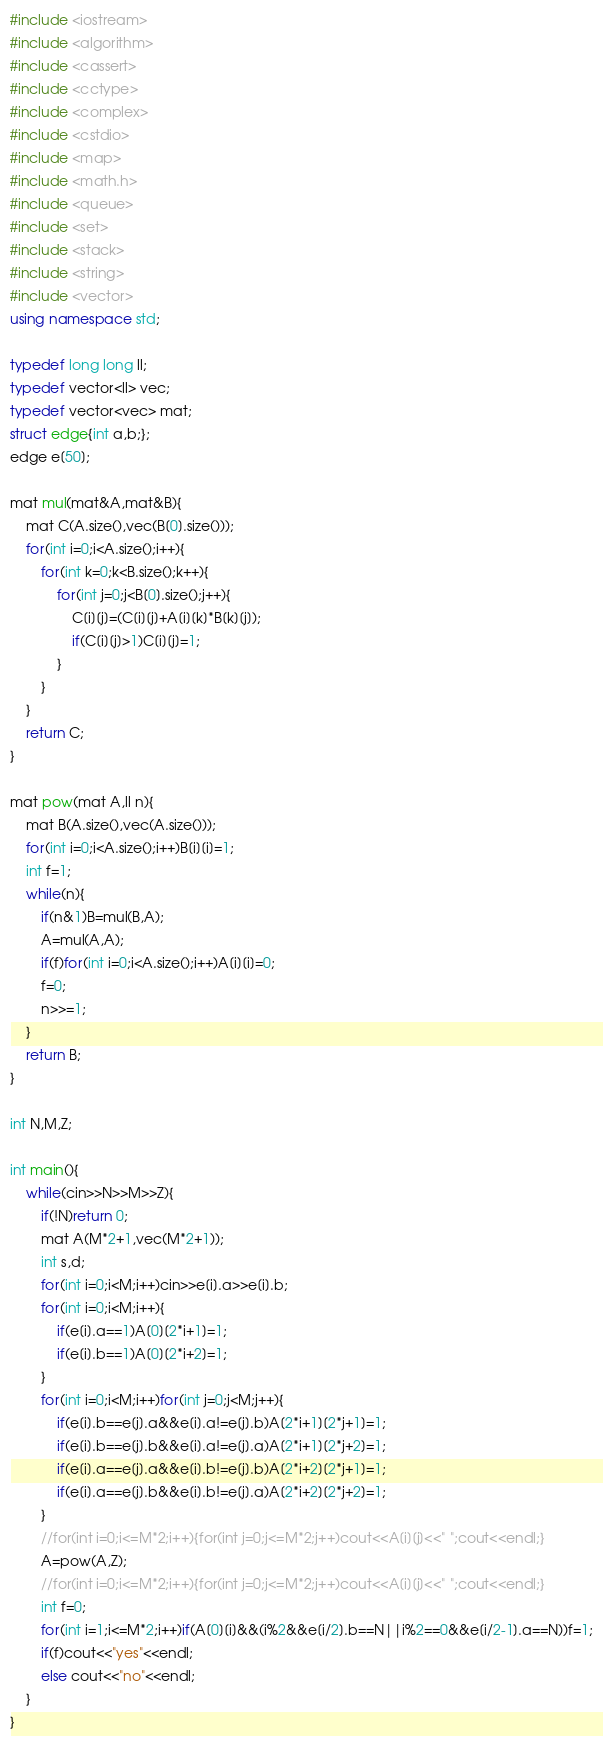<code> <loc_0><loc_0><loc_500><loc_500><_C++_>#include <iostream>
#include <algorithm>
#include <cassert>
#include <cctype>
#include <complex>
#include <cstdio>
#include <map>
#include <math.h>
#include <queue>
#include <set>
#include <stack>
#include <string>
#include <vector>
using namespace std;

typedef long long ll;
typedef vector<ll> vec;
typedef vector<vec> mat;
struct edge{int a,b;};
edge e[50];

mat mul(mat&A,mat&B){
	mat C(A.size(),vec(B[0].size()));
	for(int i=0;i<A.size();i++){
		for(int k=0;k<B.size();k++){
			for(int j=0;j<B[0].size();j++){
				C[i][j]=(C[i][j]+A[i][k]*B[k][j]);
				if(C[i][j]>1)C[i][j]=1;
			}
		}
	}
	return C;
}

mat pow(mat A,ll n){
	mat B(A.size(),vec(A.size()));
	for(int i=0;i<A.size();i++)B[i][i]=1;
	int f=1;
	while(n){
		if(n&1)B=mul(B,A);
		A=mul(A,A);
		if(f)for(int i=0;i<A.size();i++)A[i][i]=0;
		f=0;
		n>>=1;
	}
	return B;
}

int N,M,Z;

int main(){
	while(cin>>N>>M>>Z){
		if(!N)return 0;
		mat A(M*2+1,vec(M*2+1));
		int s,d;
		for(int i=0;i<M;i++)cin>>e[i].a>>e[i].b;
		for(int i=0;i<M;i++){
			if(e[i].a==1)A[0][2*i+1]=1;
			if(e[i].b==1)A[0][2*i+2]=1;
		}
		for(int i=0;i<M;i++)for(int j=0;j<M;j++){
			if(e[i].b==e[j].a&&e[i].a!=e[j].b)A[2*i+1][2*j+1]=1;
			if(e[i].b==e[j].b&&e[i].a!=e[j].a)A[2*i+1][2*j+2]=1;
			if(e[i].a==e[j].a&&e[i].b!=e[j].b)A[2*i+2][2*j+1]=1;
			if(e[i].a==e[j].b&&e[i].b!=e[j].a)A[2*i+2][2*j+2]=1;
		}
		//for(int i=0;i<=M*2;i++){for(int j=0;j<=M*2;j++)cout<<A[i][j]<<" ";cout<<endl;}
		A=pow(A,Z);
		//for(int i=0;i<=M*2;i++){for(int j=0;j<=M*2;j++)cout<<A[i][j]<<" ";cout<<endl;}
		int f=0;
		for(int i=1;i<=M*2;i++)if(A[0][i]&&(i%2&&e[i/2].b==N||i%2==0&&e[i/2-1].a==N))f=1;
		if(f)cout<<"yes"<<endl;
		else cout<<"no"<<endl;
	}
}</code> 